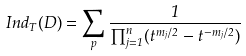Convert formula to latex. <formula><loc_0><loc_0><loc_500><loc_500>I n d _ { T } ( D ) = \sum _ { p } \frac { 1 } { \prod _ { j = 1 } ^ { n } ( t ^ { m _ { j } / 2 } - t ^ { - m _ { j } / 2 } ) }</formula> 